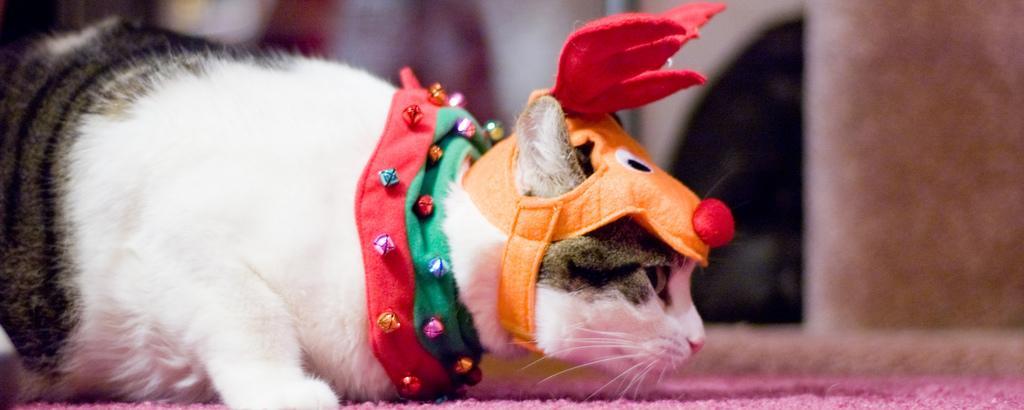Describe this image in one or two sentences. In this picture there is a cat and there is an orange color cap on the cat. At the back it looks like a wall. At the bottom there is a pink color mat. 